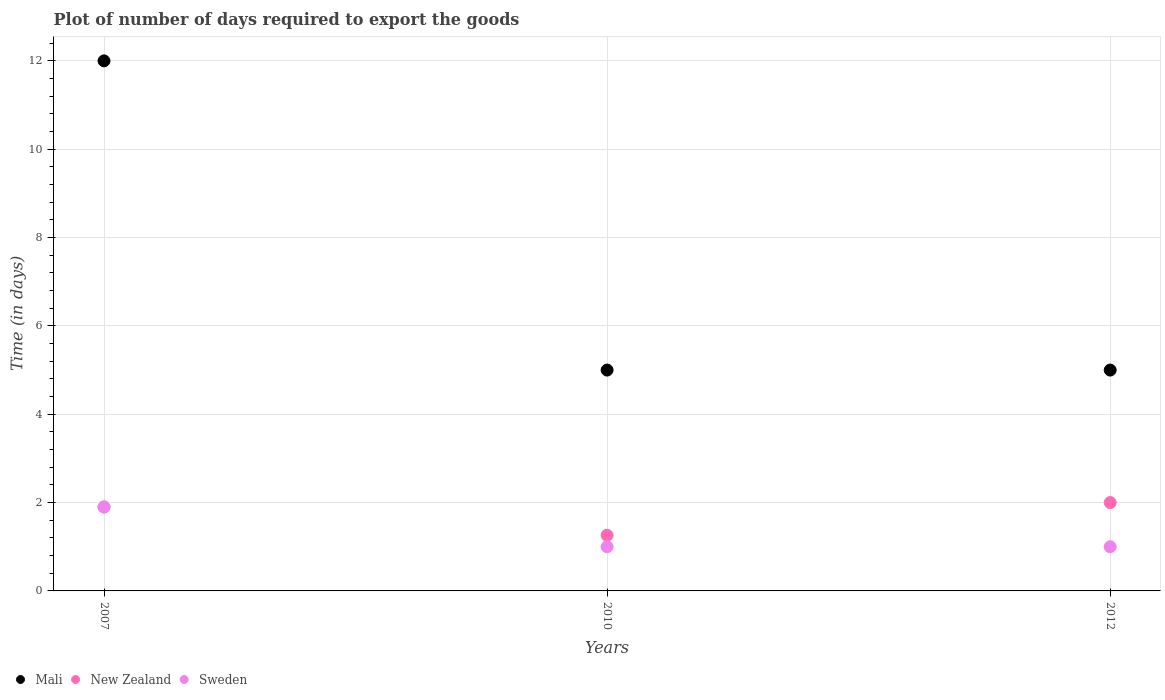What is the time required to export goods in Mali in 2012?
Your answer should be very brief. 5. Across all years, what is the minimum time required to export goods in New Zealand?
Offer a very short reply. 1.26. In which year was the time required to export goods in Mali maximum?
Provide a succinct answer. 2007. In which year was the time required to export goods in Mali minimum?
Your answer should be compact. 2010. What is the total time required to export goods in New Zealand in the graph?
Provide a short and direct response. 5.16. What is the difference between the time required to export goods in Mali in 2007 and that in 2010?
Your answer should be compact. 7. What is the difference between the time required to export goods in New Zealand in 2007 and the time required to export goods in Mali in 2010?
Ensure brevity in your answer.  -3.1. What is the average time required to export goods in New Zealand per year?
Your response must be concise. 1.72. In the year 2007, what is the difference between the time required to export goods in New Zealand and time required to export goods in Sweden?
Your answer should be very brief. 0. Is the difference between the time required to export goods in New Zealand in 2007 and 2012 greater than the difference between the time required to export goods in Sweden in 2007 and 2012?
Your response must be concise. No. What is the difference between the highest and the second highest time required to export goods in Sweden?
Ensure brevity in your answer.  0.9. What is the difference between the highest and the lowest time required to export goods in Mali?
Provide a succinct answer. 7. Is the sum of the time required to export goods in Mali in 2007 and 2012 greater than the maximum time required to export goods in New Zealand across all years?
Your answer should be compact. Yes. Is the time required to export goods in Mali strictly greater than the time required to export goods in New Zealand over the years?
Provide a succinct answer. Yes. Is the time required to export goods in Mali strictly less than the time required to export goods in New Zealand over the years?
Your response must be concise. No. How many dotlines are there?
Offer a very short reply. 3. Does the graph contain any zero values?
Give a very brief answer. No. What is the title of the graph?
Make the answer very short. Plot of number of days required to export the goods. Does "South Africa" appear as one of the legend labels in the graph?
Your response must be concise. No. What is the label or title of the X-axis?
Ensure brevity in your answer.  Years. What is the label or title of the Y-axis?
Give a very brief answer. Time (in days). What is the Time (in days) in Mali in 2007?
Provide a short and direct response. 12. What is the Time (in days) of New Zealand in 2007?
Keep it short and to the point. 1.9. What is the Time (in days) of Sweden in 2007?
Provide a succinct answer. 1.9. What is the Time (in days) of Mali in 2010?
Your response must be concise. 5. What is the Time (in days) in New Zealand in 2010?
Your answer should be very brief. 1.26. What is the Time (in days) of Sweden in 2010?
Your answer should be compact. 1. What is the Time (in days) in New Zealand in 2012?
Your answer should be very brief. 2. What is the Time (in days) in Sweden in 2012?
Provide a succinct answer. 1. Across all years, what is the maximum Time (in days) of New Zealand?
Offer a terse response. 2. Across all years, what is the minimum Time (in days) of New Zealand?
Provide a succinct answer. 1.26. Across all years, what is the minimum Time (in days) in Sweden?
Keep it short and to the point. 1. What is the total Time (in days) in Mali in the graph?
Provide a succinct answer. 22. What is the total Time (in days) in New Zealand in the graph?
Keep it short and to the point. 5.16. What is the total Time (in days) in Sweden in the graph?
Your response must be concise. 3.9. What is the difference between the Time (in days) in New Zealand in 2007 and that in 2010?
Offer a very short reply. 0.64. What is the difference between the Time (in days) of Sweden in 2007 and that in 2010?
Provide a short and direct response. 0.9. What is the difference between the Time (in days) in Mali in 2007 and that in 2012?
Make the answer very short. 7. What is the difference between the Time (in days) in New Zealand in 2010 and that in 2012?
Give a very brief answer. -0.74. What is the difference between the Time (in days) in Sweden in 2010 and that in 2012?
Your answer should be compact. 0. What is the difference between the Time (in days) in Mali in 2007 and the Time (in days) in New Zealand in 2010?
Make the answer very short. 10.74. What is the difference between the Time (in days) of Mali in 2007 and the Time (in days) of Sweden in 2010?
Your response must be concise. 11. What is the difference between the Time (in days) in New Zealand in 2007 and the Time (in days) in Sweden in 2010?
Keep it short and to the point. 0.9. What is the difference between the Time (in days) in Mali in 2007 and the Time (in days) in Sweden in 2012?
Give a very brief answer. 11. What is the difference between the Time (in days) of New Zealand in 2010 and the Time (in days) of Sweden in 2012?
Your response must be concise. 0.26. What is the average Time (in days) in Mali per year?
Provide a succinct answer. 7.33. What is the average Time (in days) in New Zealand per year?
Your response must be concise. 1.72. In the year 2007, what is the difference between the Time (in days) of Mali and Time (in days) of New Zealand?
Provide a short and direct response. 10.1. In the year 2010, what is the difference between the Time (in days) of Mali and Time (in days) of New Zealand?
Offer a very short reply. 3.74. In the year 2010, what is the difference between the Time (in days) of New Zealand and Time (in days) of Sweden?
Offer a terse response. 0.26. In the year 2012, what is the difference between the Time (in days) in New Zealand and Time (in days) in Sweden?
Offer a very short reply. 1. What is the ratio of the Time (in days) of New Zealand in 2007 to that in 2010?
Keep it short and to the point. 1.51. What is the ratio of the Time (in days) in New Zealand in 2010 to that in 2012?
Provide a short and direct response. 0.63. What is the ratio of the Time (in days) in Sweden in 2010 to that in 2012?
Offer a very short reply. 1. What is the difference between the highest and the second highest Time (in days) of New Zealand?
Ensure brevity in your answer.  0.1. What is the difference between the highest and the lowest Time (in days) of New Zealand?
Your response must be concise. 0.74. 